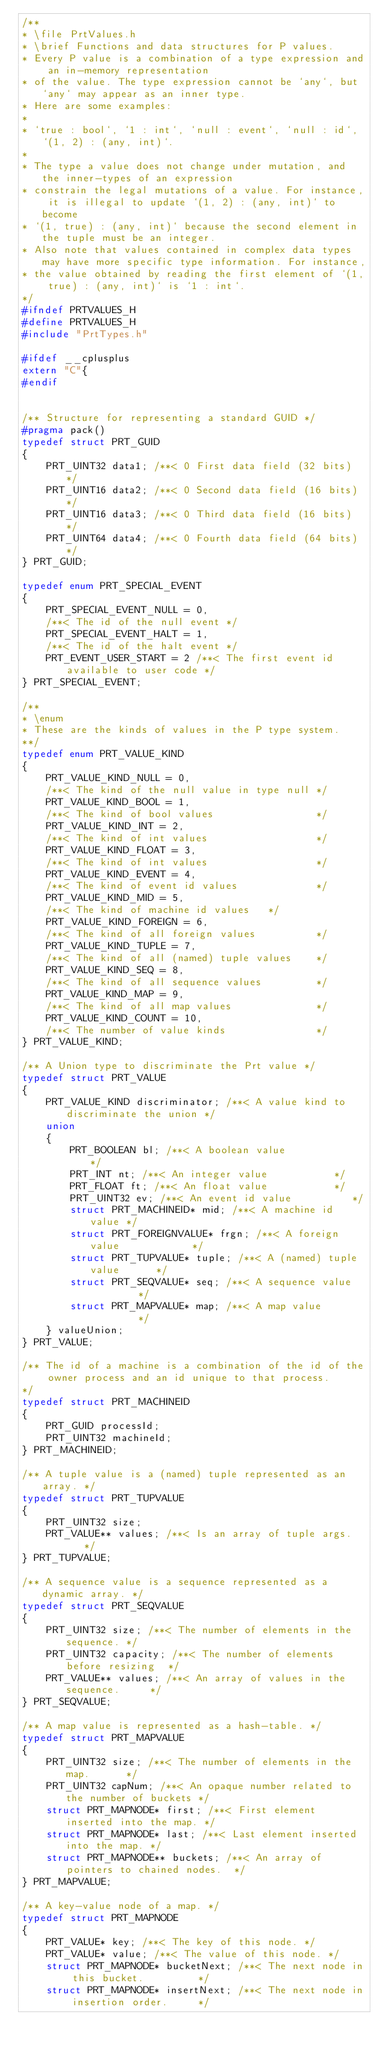Convert code to text. <code><loc_0><loc_0><loc_500><loc_500><_C_>/**
* \file PrtValues.h
* \brief Functions and data structures for P values.
* Every P value is a combination of a type expression and an in-memory representation
* of the value. The type expression cannot be `any`, but `any` may appear as an inner type.
* Here are some examples:
*
* `true : bool`, `1 : int`, `null : event`, `null : id`, `(1, 2) : (any, int)`.
*
* The type a value does not change under mutation, and the inner-types of an expression
* constrain the legal mutations of a value. For instance, it is illegal to update `(1, 2) : (any, int)` to become
* `(1, true) : (any, int)` because the second element in the tuple must be an integer.
* Also note that values contained in complex data types may have more specific type information. For instance,
* the value obtained by reading the first element of `(1, true) : (any, int)` is `1 : int`.
*/
#ifndef PRTVALUES_H
#define PRTVALUES_H
#include "PrtTypes.h"

#ifdef __cplusplus
extern "C"{
#endif


/** Structure for representing a standard GUID */
#pragma pack()
typedef struct PRT_GUID
{
	PRT_UINT32 data1; /**< 0 First data field (32 bits)  */
	PRT_UINT16 data2; /**< 0 Second data field (16 bits) */
	PRT_UINT16 data3; /**< 0 Third data field (16 bits)  */
	PRT_UINT64 data4; /**< 0 Fourth data field (64 bits) */
} PRT_GUID;

typedef enum PRT_SPECIAL_EVENT
{
	PRT_SPECIAL_EVENT_NULL = 0,
	/**< The id of the null event */
	PRT_SPECIAL_EVENT_HALT = 1,
	/**< The id of the halt event */
	PRT_EVENT_USER_START = 2 /**< The first event id available to user code */
} PRT_SPECIAL_EVENT;

/**
* \enum
* These are the kinds of values in the P type system.
**/
typedef enum PRT_VALUE_KIND
{
	PRT_VALUE_KIND_NULL = 0,
	/**< The kind of the null value in type null */
	PRT_VALUE_KIND_BOOL = 1,
	/**< The kind of bool values                 */
	PRT_VALUE_KIND_INT = 2,
	/**< The kind of int values                  */
	PRT_VALUE_KIND_FLOAT = 3,
	/**< The kind of int values                  */
	PRT_VALUE_KIND_EVENT = 4,
	/**< The kind of event id values             */
	PRT_VALUE_KIND_MID = 5,
	/**< The kind of machine id values   */
	PRT_VALUE_KIND_FOREIGN = 6,
	/**< The kind of all foreign values          */
	PRT_VALUE_KIND_TUPLE = 7,
	/**< The kind of all (named) tuple values    */
	PRT_VALUE_KIND_SEQ = 8,
	/**< The kind of all sequence values         */
	PRT_VALUE_KIND_MAP = 9,
	/**< The kind of all map values              */
	PRT_VALUE_KIND_COUNT = 10,
	/**< The number of value kinds               */
} PRT_VALUE_KIND;

/** A Union type to discriminate the Prt value */
typedef struct PRT_VALUE
{
	PRT_VALUE_KIND discriminator; /**< A value kind to discriminate the union */
	union
	{
		PRT_BOOLEAN bl; /**< A boolean value            */
		PRT_INT nt; /**< An integer value           */
		PRT_FLOAT ft; /**< An float value           */
		PRT_UINT32 ev; /**< An event id value          */
		struct PRT_MACHINEID* mid; /**< A machine id value */
		struct PRT_FOREIGNVALUE* frgn; /**< A foreign value            */
		struct PRT_TUPVALUE* tuple; /**< A (named) tuple value      */
		struct PRT_SEQVALUE* seq; /**< A sequence value	        */
		struct PRT_MAPVALUE* map; /**< A map value		        */
	} valueUnion;
} PRT_VALUE;

/** The id of a machine is a combination of the id of the owner process and an id unique to that process.
*/
typedef struct PRT_MACHINEID
{
	PRT_GUID processId;
	PRT_UINT32 machineId;
} PRT_MACHINEID;

/** A tuple value is a (named) tuple represented as an array. */
typedef struct PRT_TUPVALUE
{
	PRT_UINT32 size;
	PRT_VALUE** values; /**< Is an array of tuple args.    */
} PRT_TUPVALUE;

/** A sequence value is a sequence represented as a dynamic array. */
typedef struct PRT_SEQVALUE
{
	PRT_UINT32 size; /**< The number of elements in the sequence. */
	PRT_UINT32 capacity; /**< The number of elements before resizing  */
	PRT_VALUE** values; /**< An array of values in the sequence.     */
} PRT_SEQVALUE;

/** A map value is represented as a hash-table. */
typedef struct PRT_MAPVALUE
{
	PRT_UINT32 size; /**< The number of elements in the map.      */
	PRT_UINT32 capNum; /**< An opaque number related to the number of buckets */
	struct PRT_MAPNODE* first; /**< First element inserted into the map. */
	struct PRT_MAPNODE* last; /**< Last element inserted into the map. */
	struct PRT_MAPNODE** buckets; /**< An array of pointers to chained nodes.  */
} PRT_MAPVALUE;

/** A key-value node of a map. */
typedef struct PRT_MAPNODE
{
	PRT_VALUE* key; /**< The key of this node. */
	PRT_VALUE* value; /**< The value of this node. */
	struct PRT_MAPNODE* bucketNext; /**< The next node in this bucket.         */
	struct PRT_MAPNODE* insertNext; /**< The next node in insertion order.     */</code> 